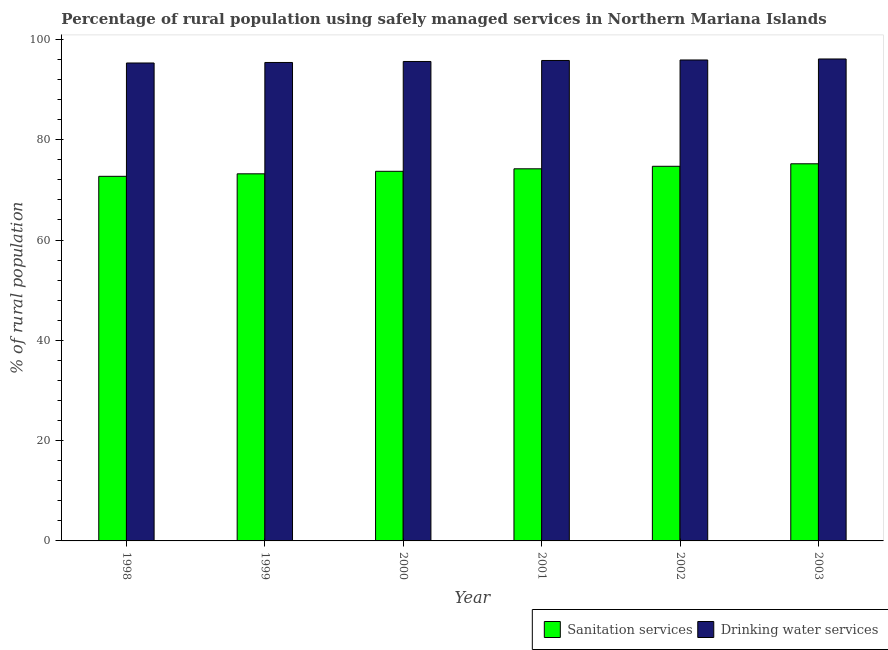Are the number of bars per tick equal to the number of legend labels?
Offer a terse response. Yes. How many bars are there on the 1st tick from the left?
Offer a terse response. 2. How many bars are there on the 3rd tick from the right?
Ensure brevity in your answer.  2. What is the label of the 3rd group of bars from the left?
Give a very brief answer. 2000. In how many cases, is the number of bars for a given year not equal to the number of legend labels?
Offer a very short reply. 0. What is the percentage of rural population who used drinking water services in 1998?
Make the answer very short. 95.3. Across all years, what is the maximum percentage of rural population who used drinking water services?
Your answer should be compact. 96.1. Across all years, what is the minimum percentage of rural population who used sanitation services?
Provide a succinct answer. 72.7. In which year was the percentage of rural population who used sanitation services maximum?
Give a very brief answer. 2003. In which year was the percentage of rural population who used drinking water services minimum?
Offer a terse response. 1998. What is the total percentage of rural population who used sanitation services in the graph?
Provide a succinct answer. 443.7. What is the difference between the percentage of rural population who used drinking water services in 2000 and that in 2001?
Your response must be concise. -0.2. What is the difference between the percentage of rural population who used drinking water services in 2000 and the percentage of rural population who used sanitation services in 2002?
Keep it short and to the point. -0.3. What is the average percentage of rural population who used drinking water services per year?
Offer a very short reply. 95.68. In the year 2001, what is the difference between the percentage of rural population who used sanitation services and percentage of rural population who used drinking water services?
Offer a terse response. 0. What is the ratio of the percentage of rural population who used drinking water services in 1999 to that in 2001?
Make the answer very short. 1. What is the difference between the highest and the lowest percentage of rural population who used drinking water services?
Offer a very short reply. 0.8. In how many years, is the percentage of rural population who used drinking water services greater than the average percentage of rural population who used drinking water services taken over all years?
Your answer should be compact. 3. What does the 1st bar from the left in 2002 represents?
Your answer should be very brief. Sanitation services. What does the 1st bar from the right in 1999 represents?
Provide a succinct answer. Drinking water services. How many bars are there?
Provide a short and direct response. 12. How many years are there in the graph?
Your response must be concise. 6. How are the legend labels stacked?
Offer a terse response. Horizontal. What is the title of the graph?
Your answer should be compact. Percentage of rural population using safely managed services in Northern Mariana Islands. Does "Non-residents" appear as one of the legend labels in the graph?
Provide a short and direct response. No. What is the label or title of the X-axis?
Your answer should be very brief. Year. What is the label or title of the Y-axis?
Make the answer very short. % of rural population. What is the % of rural population of Sanitation services in 1998?
Your answer should be very brief. 72.7. What is the % of rural population in Drinking water services in 1998?
Your answer should be very brief. 95.3. What is the % of rural population of Sanitation services in 1999?
Provide a short and direct response. 73.2. What is the % of rural population of Drinking water services in 1999?
Give a very brief answer. 95.4. What is the % of rural population in Sanitation services in 2000?
Give a very brief answer. 73.7. What is the % of rural population in Drinking water services in 2000?
Your answer should be compact. 95.6. What is the % of rural population in Sanitation services in 2001?
Your response must be concise. 74.2. What is the % of rural population in Drinking water services in 2001?
Your response must be concise. 95.8. What is the % of rural population of Sanitation services in 2002?
Make the answer very short. 74.7. What is the % of rural population in Drinking water services in 2002?
Ensure brevity in your answer.  95.9. What is the % of rural population of Sanitation services in 2003?
Give a very brief answer. 75.2. What is the % of rural population of Drinking water services in 2003?
Your answer should be very brief. 96.1. Across all years, what is the maximum % of rural population of Sanitation services?
Make the answer very short. 75.2. Across all years, what is the maximum % of rural population in Drinking water services?
Give a very brief answer. 96.1. Across all years, what is the minimum % of rural population in Sanitation services?
Provide a succinct answer. 72.7. Across all years, what is the minimum % of rural population in Drinking water services?
Provide a short and direct response. 95.3. What is the total % of rural population in Sanitation services in the graph?
Provide a short and direct response. 443.7. What is the total % of rural population of Drinking water services in the graph?
Ensure brevity in your answer.  574.1. What is the difference between the % of rural population in Sanitation services in 1998 and that in 2000?
Make the answer very short. -1. What is the difference between the % of rural population of Sanitation services in 1998 and that in 2001?
Provide a short and direct response. -1.5. What is the difference between the % of rural population in Drinking water services in 1998 and that in 2001?
Provide a short and direct response. -0.5. What is the difference between the % of rural population of Sanitation services in 1998 and that in 2003?
Your response must be concise. -2.5. What is the difference between the % of rural population of Drinking water services in 1998 and that in 2003?
Your response must be concise. -0.8. What is the difference between the % of rural population in Drinking water services in 1999 and that in 2000?
Offer a very short reply. -0.2. What is the difference between the % of rural population of Sanitation services in 1999 and that in 2001?
Keep it short and to the point. -1. What is the difference between the % of rural population of Sanitation services in 1999 and that in 2002?
Your answer should be very brief. -1.5. What is the difference between the % of rural population in Sanitation services in 2000 and that in 2001?
Your answer should be very brief. -0.5. What is the difference between the % of rural population of Drinking water services in 2000 and that in 2002?
Your answer should be compact. -0.3. What is the difference between the % of rural population of Sanitation services in 2000 and that in 2003?
Provide a succinct answer. -1.5. What is the difference between the % of rural population of Drinking water services in 2001 and that in 2002?
Provide a short and direct response. -0.1. What is the difference between the % of rural population in Drinking water services in 2001 and that in 2003?
Ensure brevity in your answer.  -0.3. What is the difference between the % of rural population of Drinking water services in 2002 and that in 2003?
Make the answer very short. -0.2. What is the difference between the % of rural population of Sanitation services in 1998 and the % of rural population of Drinking water services in 1999?
Offer a terse response. -22.7. What is the difference between the % of rural population in Sanitation services in 1998 and the % of rural population in Drinking water services in 2000?
Provide a short and direct response. -22.9. What is the difference between the % of rural population of Sanitation services in 1998 and the % of rural population of Drinking water services in 2001?
Your answer should be very brief. -23.1. What is the difference between the % of rural population in Sanitation services in 1998 and the % of rural population in Drinking water services in 2002?
Give a very brief answer. -23.2. What is the difference between the % of rural population in Sanitation services in 1998 and the % of rural population in Drinking water services in 2003?
Your answer should be very brief. -23.4. What is the difference between the % of rural population in Sanitation services in 1999 and the % of rural population in Drinking water services in 2000?
Provide a succinct answer. -22.4. What is the difference between the % of rural population of Sanitation services in 1999 and the % of rural population of Drinking water services in 2001?
Make the answer very short. -22.6. What is the difference between the % of rural population of Sanitation services in 1999 and the % of rural population of Drinking water services in 2002?
Ensure brevity in your answer.  -22.7. What is the difference between the % of rural population in Sanitation services in 1999 and the % of rural population in Drinking water services in 2003?
Ensure brevity in your answer.  -22.9. What is the difference between the % of rural population of Sanitation services in 2000 and the % of rural population of Drinking water services in 2001?
Give a very brief answer. -22.1. What is the difference between the % of rural population in Sanitation services in 2000 and the % of rural population in Drinking water services in 2002?
Offer a very short reply. -22.2. What is the difference between the % of rural population of Sanitation services in 2000 and the % of rural population of Drinking water services in 2003?
Keep it short and to the point. -22.4. What is the difference between the % of rural population in Sanitation services in 2001 and the % of rural population in Drinking water services in 2002?
Provide a short and direct response. -21.7. What is the difference between the % of rural population of Sanitation services in 2001 and the % of rural population of Drinking water services in 2003?
Offer a terse response. -21.9. What is the difference between the % of rural population in Sanitation services in 2002 and the % of rural population in Drinking water services in 2003?
Your answer should be very brief. -21.4. What is the average % of rural population in Sanitation services per year?
Provide a short and direct response. 73.95. What is the average % of rural population of Drinking water services per year?
Make the answer very short. 95.68. In the year 1998, what is the difference between the % of rural population of Sanitation services and % of rural population of Drinking water services?
Keep it short and to the point. -22.6. In the year 1999, what is the difference between the % of rural population in Sanitation services and % of rural population in Drinking water services?
Your response must be concise. -22.2. In the year 2000, what is the difference between the % of rural population in Sanitation services and % of rural population in Drinking water services?
Your response must be concise. -21.9. In the year 2001, what is the difference between the % of rural population in Sanitation services and % of rural population in Drinking water services?
Offer a terse response. -21.6. In the year 2002, what is the difference between the % of rural population of Sanitation services and % of rural population of Drinking water services?
Ensure brevity in your answer.  -21.2. In the year 2003, what is the difference between the % of rural population of Sanitation services and % of rural population of Drinking water services?
Give a very brief answer. -20.9. What is the ratio of the % of rural population of Sanitation services in 1998 to that in 1999?
Your answer should be compact. 0.99. What is the ratio of the % of rural population of Drinking water services in 1998 to that in 1999?
Provide a succinct answer. 1. What is the ratio of the % of rural population of Sanitation services in 1998 to that in 2000?
Keep it short and to the point. 0.99. What is the ratio of the % of rural population in Sanitation services in 1998 to that in 2001?
Offer a very short reply. 0.98. What is the ratio of the % of rural population of Drinking water services in 1998 to that in 2001?
Your answer should be very brief. 0.99. What is the ratio of the % of rural population in Sanitation services in 1998 to that in 2002?
Your answer should be compact. 0.97. What is the ratio of the % of rural population of Drinking water services in 1998 to that in 2002?
Your answer should be compact. 0.99. What is the ratio of the % of rural population of Sanitation services in 1998 to that in 2003?
Your answer should be compact. 0.97. What is the ratio of the % of rural population of Drinking water services in 1998 to that in 2003?
Ensure brevity in your answer.  0.99. What is the ratio of the % of rural population of Sanitation services in 1999 to that in 2000?
Keep it short and to the point. 0.99. What is the ratio of the % of rural population of Drinking water services in 1999 to that in 2000?
Provide a succinct answer. 1. What is the ratio of the % of rural population of Sanitation services in 1999 to that in 2001?
Make the answer very short. 0.99. What is the ratio of the % of rural population in Sanitation services in 1999 to that in 2002?
Provide a short and direct response. 0.98. What is the ratio of the % of rural population of Sanitation services in 1999 to that in 2003?
Offer a very short reply. 0.97. What is the ratio of the % of rural population in Sanitation services in 2000 to that in 2001?
Your response must be concise. 0.99. What is the ratio of the % of rural population in Sanitation services in 2000 to that in 2002?
Provide a succinct answer. 0.99. What is the ratio of the % of rural population of Sanitation services in 2000 to that in 2003?
Provide a succinct answer. 0.98. What is the ratio of the % of rural population in Drinking water services in 2001 to that in 2002?
Offer a very short reply. 1. What is the ratio of the % of rural population of Sanitation services in 2001 to that in 2003?
Give a very brief answer. 0.99. What is the ratio of the % of rural population of Drinking water services in 2001 to that in 2003?
Your response must be concise. 1. What is the ratio of the % of rural population in Sanitation services in 2002 to that in 2003?
Keep it short and to the point. 0.99. What is the ratio of the % of rural population of Drinking water services in 2002 to that in 2003?
Make the answer very short. 1. What is the difference between the highest and the second highest % of rural population of Sanitation services?
Your answer should be compact. 0.5. 